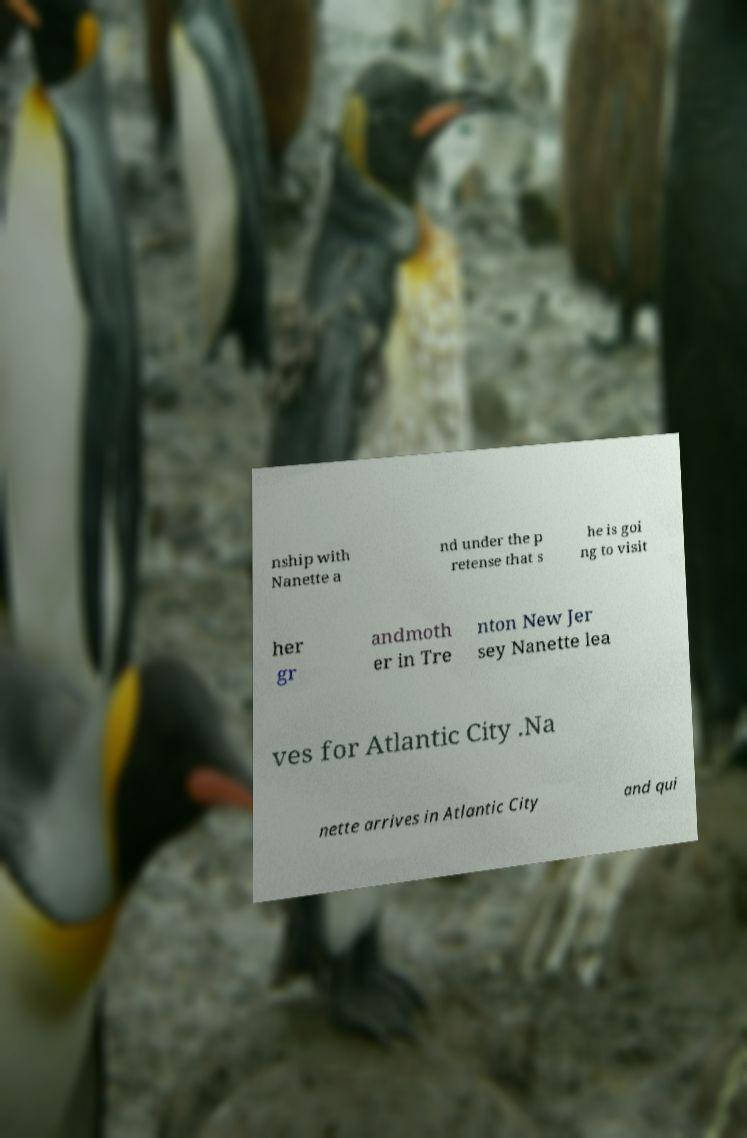There's text embedded in this image that I need extracted. Can you transcribe it verbatim? nship with Nanette a nd under the p retense that s he is goi ng to visit her gr andmoth er in Tre nton New Jer sey Nanette lea ves for Atlantic City .Na nette arrives in Atlantic City and qui 